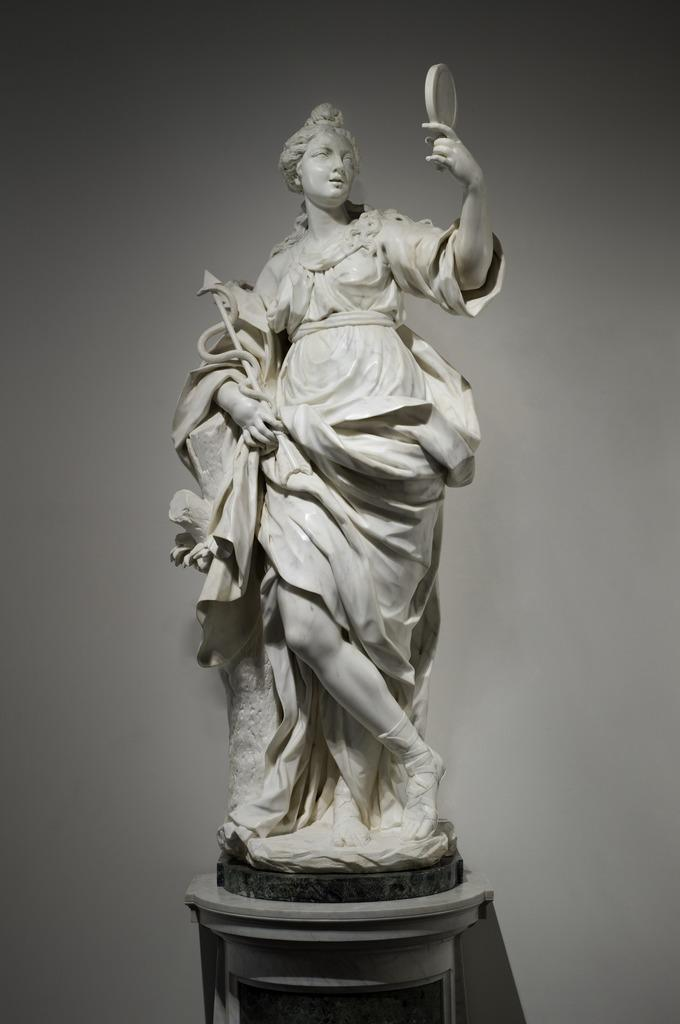What is the main subject in the image? There is a statue in the image. Where is the statue located? The statue is on a platform. What can be seen in the background of the image? There is a wall visible in the background of the image. What type of cream is being applied to the statue in the image? There is no cream being applied to the statue in the image; it is a static statue on a platform. 